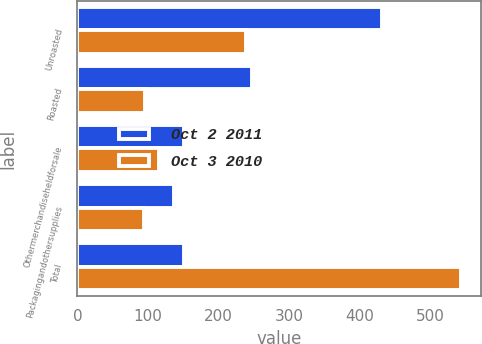Convert chart. <chart><loc_0><loc_0><loc_500><loc_500><stacked_bar_chart><ecel><fcel>Unroasted<fcel>Roasted<fcel>Othermerchandiseheldforsale<fcel>Packagingandothersupplies<fcel>Total<nl><fcel>Oct 2 2011<fcel>431.3<fcel>246.5<fcel>150.8<fcel>137.2<fcel>150.8<nl><fcel>Oct 3 2010<fcel>238.3<fcel>95.1<fcel>115.6<fcel>94.3<fcel>543.3<nl></chart> 